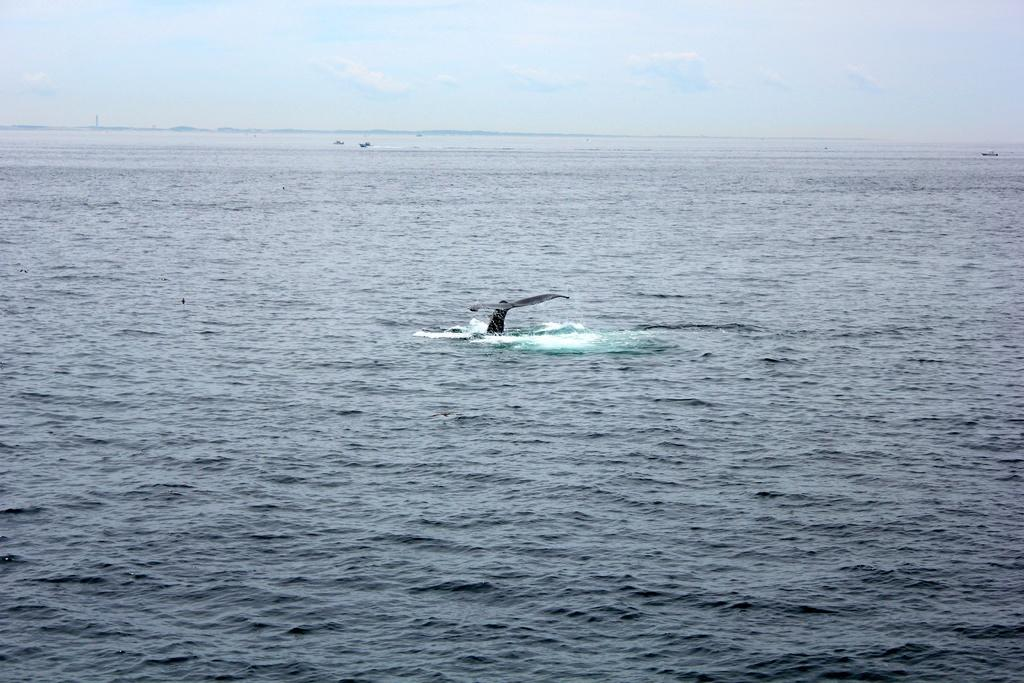What is visible in the sky in the image? The sky with clouds is visible in the image. What type of natural environment can be seen in the image? There is sea visible in the image. Can you describe any living organisms present in the image? A fish from the water is present in the image. What type of park can be seen in the image? There is no park present in the image; it features the sky with clouds and sea. Can you describe the texture of the cloud in the image? The provided facts do not mention the texture of the cloud, so it cannot be described. 